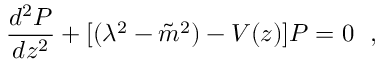Convert formula to latex. <formula><loc_0><loc_0><loc_500><loc_500>\frac { d ^ { 2 } P } { d z ^ { 2 } } + [ ( \lambda ^ { 2 } - { \tilde { m } } ^ { 2 } ) - V ( z ) ] P = 0 ,</formula> 